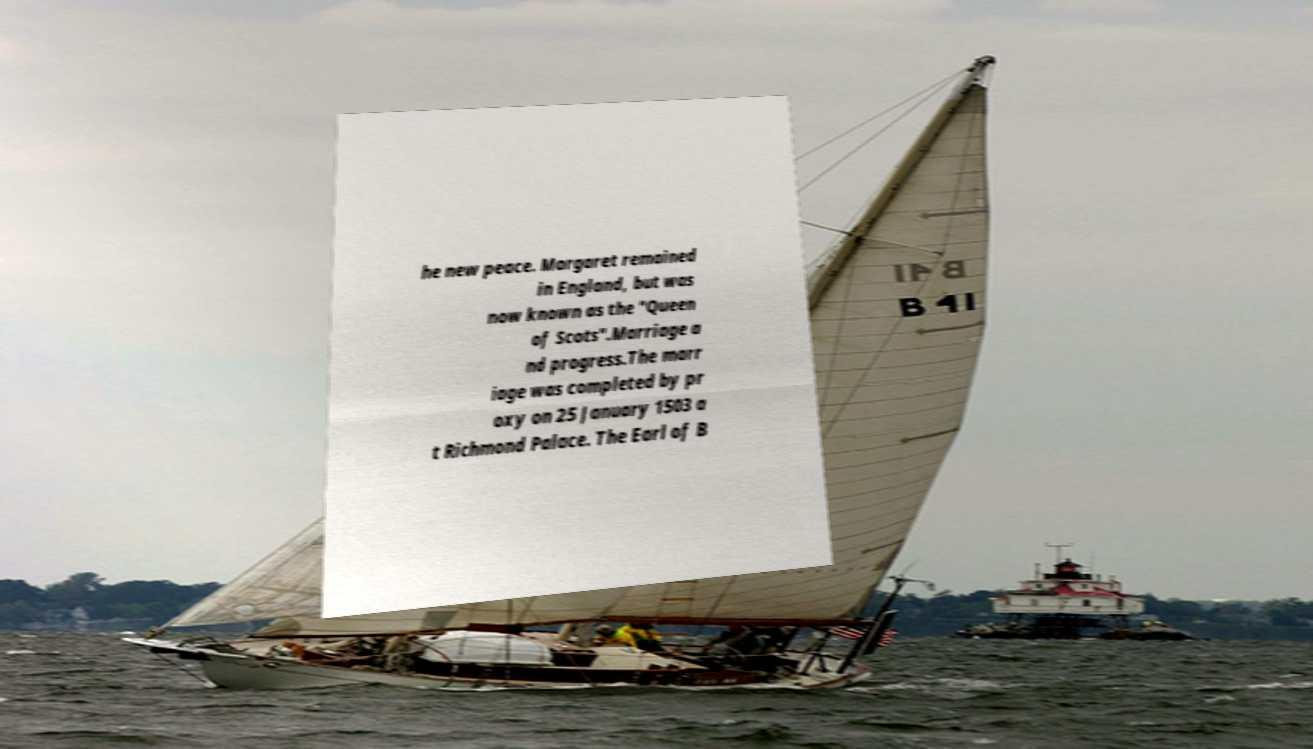Could you assist in decoding the text presented in this image and type it out clearly? he new peace. Margaret remained in England, but was now known as the "Queen of Scots".Marriage a nd progress.The marr iage was completed by pr oxy on 25 January 1503 a t Richmond Palace. The Earl of B 